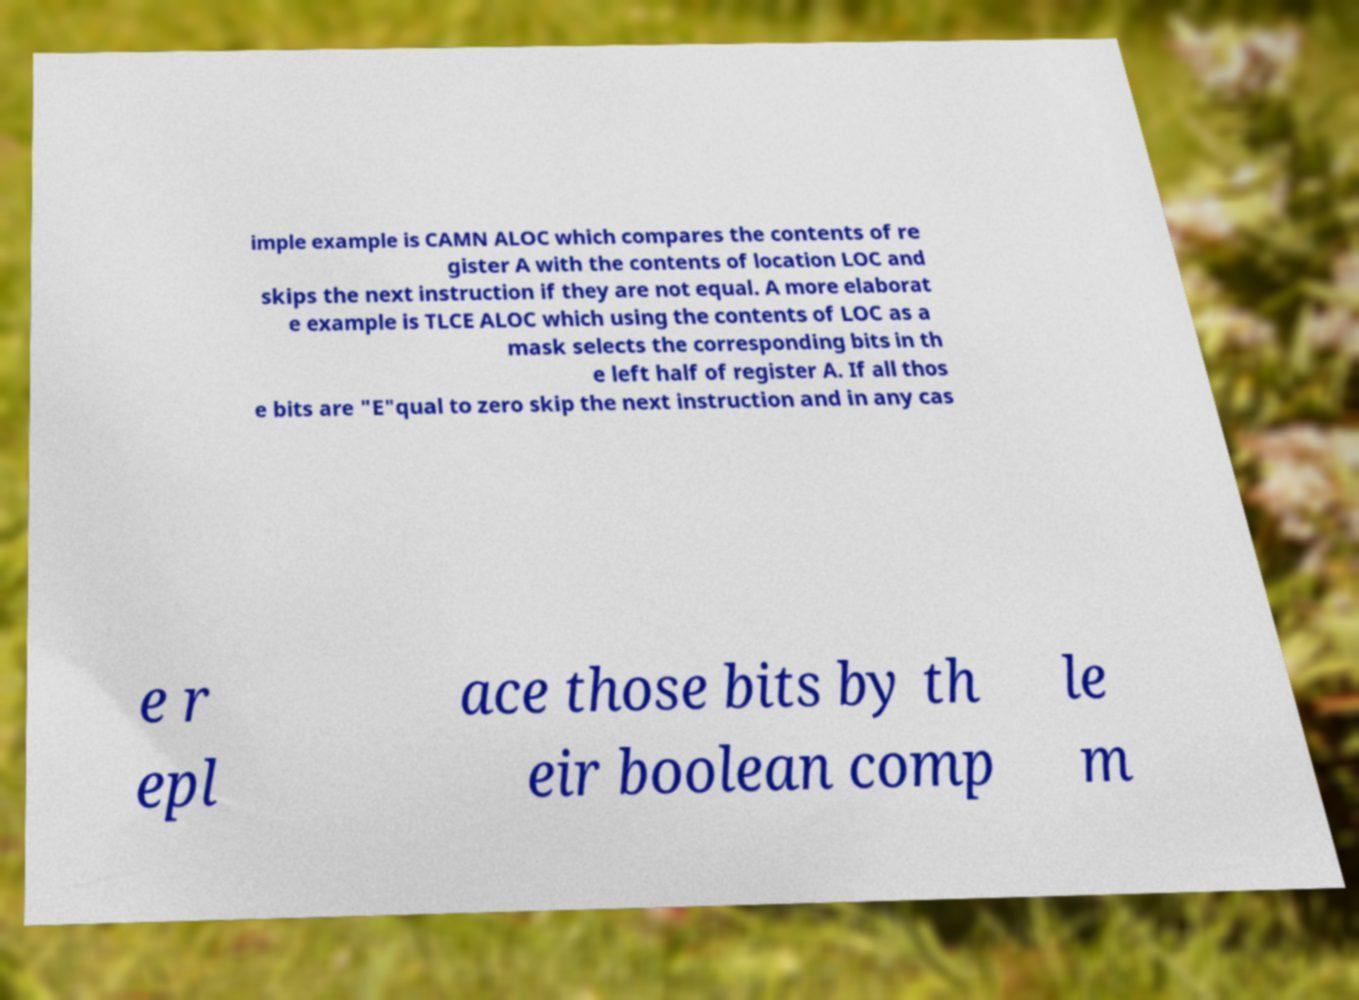Could you extract and type out the text from this image? imple example is CAMN ALOC which compares the contents of re gister A with the contents of location LOC and skips the next instruction if they are not equal. A more elaborat e example is TLCE ALOC which using the contents of LOC as a mask selects the corresponding bits in th e left half of register A. If all thos e bits are "E"qual to zero skip the next instruction and in any cas e r epl ace those bits by th eir boolean comp le m 